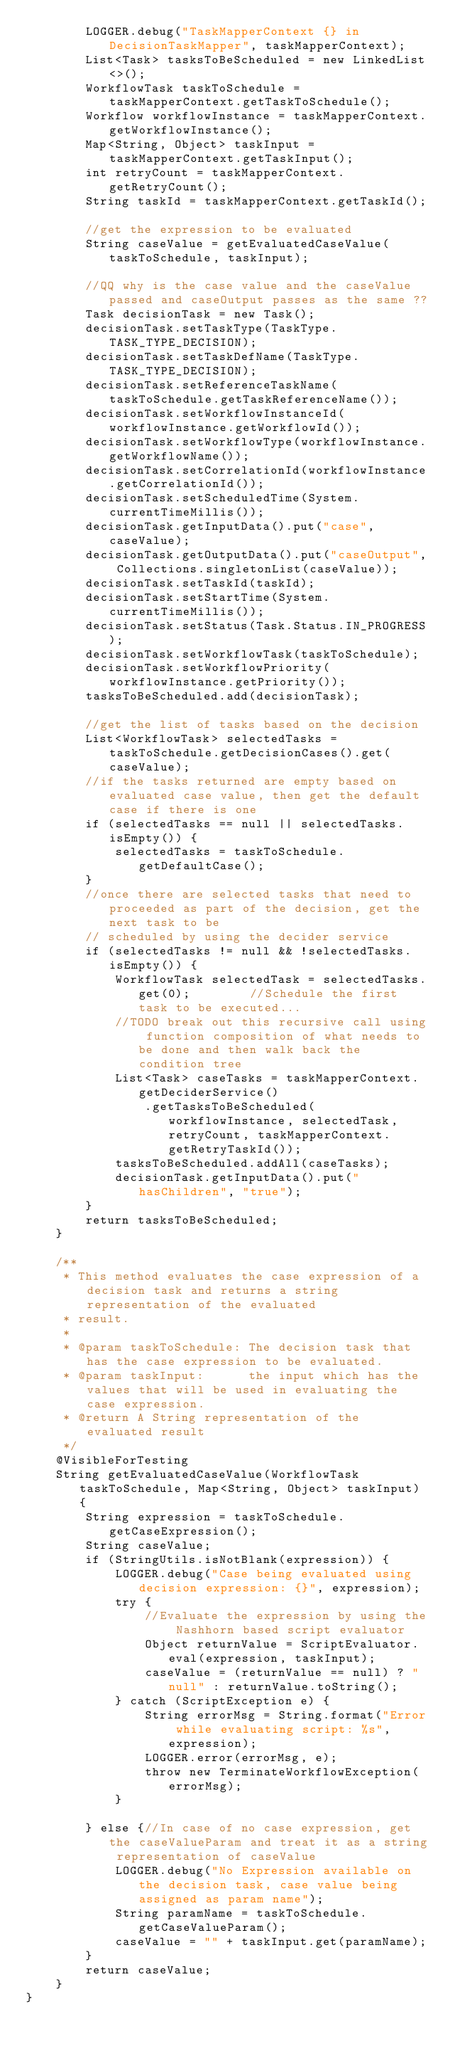<code> <loc_0><loc_0><loc_500><loc_500><_Java_>        LOGGER.debug("TaskMapperContext {} in DecisionTaskMapper", taskMapperContext);
        List<Task> tasksToBeScheduled = new LinkedList<>();
        WorkflowTask taskToSchedule = taskMapperContext.getTaskToSchedule();
        Workflow workflowInstance = taskMapperContext.getWorkflowInstance();
        Map<String, Object> taskInput = taskMapperContext.getTaskInput();
        int retryCount = taskMapperContext.getRetryCount();
        String taskId = taskMapperContext.getTaskId();

        //get the expression to be evaluated
        String caseValue = getEvaluatedCaseValue(taskToSchedule, taskInput);

        //QQ why is the case value and the caseValue passed and caseOutput passes as the same ??
        Task decisionTask = new Task();
        decisionTask.setTaskType(TaskType.TASK_TYPE_DECISION);
        decisionTask.setTaskDefName(TaskType.TASK_TYPE_DECISION);
        decisionTask.setReferenceTaskName(taskToSchedule.getTaskReferenceName());
        decisionTask.setWorkflowInstanceId(workflowInstance.getWorkflowId());
        decisionTask.setWorkflowType(workflowInstance.getWorkflowName());
        decisionTask.setCorrelationId(workflowInstance.getCorrelationId());
        decisionTask.setScheduledTime(System.currentTimeMillis());
        decisionTask.getInputData().put("case", caseValue);
        decisionTask.getOutputData().put("caseOutput", Collections.singletonList(caseValue));
        decisionTask.setTaskId(taskId);
        decisionTask.setStartTime(System.currentTimeMillis());
        decisionTask.setStatus(Task.Status.IN_PROGRESS);
        decisionTask.setWorkflowTask(taskToSchedule);
        decisionTask.setWorkflowPriority(workflowInstance.getPriority());
        tasksToBeScheduled.add(decisionTask);

        //get the list of tasks based on the decision
        List<WorkflowTask> selectedTasks = taskToSchedule.getDecisionCases().get(caseValue);
        //if the tasks returned are empty based on evaluated case value, then get the default case if there is one
        if (selectedTasks == null || selectedTasks.isEmpty()) {
            selectedTasks = taskToSchedule.getDefaultCase();
        }
        //once there are selected tasks that need to proceeded as part of the decision, get the next task to be
        // scheduled by using the decider service
        if (selectedTasks != null && !selectedTasks.isEmpty()) {
            WorkflowTask selectedTask = selectedTasks.get(0);        //Schedule the first task to be executed...
            //TODO break out this recursive call using function composition of what needs to be done and then walk back the condition tree
            List<Task> caseTasks = taskMapperContext.getDeciderService()
                .getTasksToBeScheduled(workflowInstance, selectedTask, retryCount, taskMapperContext.getRetryTaskId());
            tasksToBeScheduled.addAll(caseTasks);
            decisionTask.getInputData().put("hasChildren", "true");
        }
        return tasksToBeScheduled;
    }

    /**
     * This method evaluates the case expression of a decision task and returns a string representation of the evaluated
     * result.
     *
     * @param taskToSchedule: The decision task that has the case expression to be evaluated.
     * @param taskInput:      the input which has the values that will be used in evaluating the case expression.
     * @return A String representation of the evaluated result
     */
    @VisibleForTesting
    String getEvaluatedCaseValue(WorkflowTask taskToSchedule, Map<String, Object> taskInput) {
        String expression = taskToSchedule.getCaseExpression();
        String caseValue;
        if (StringUtils.isNotBlank(expression)) {
            LOGGER.debug("Case being evaluated using decision expression: {}", expression);
            try {
                //Evaluate the expression by using the Nashhorn based script evaluator
                Object returnValue = ScriptEvaluator.eval(expression, taskInput);
                caseValue = (returnValue == null) ? "null" : returnValue.toString();
            } catch (ScriptException e) {
                String errorMsg = String.format("Error while evaluating script: %s", expression);
                LOGGER.error(errorMsg, e);
                throw new TerminateWorkflowException(errorMsg);
            }

        } else {//In case of no case expression, get the caseValueParam and treat it as a string representation of caseValue
            LOGGER.debug("No Expression available on the decision task, case value being assigned as param name");
            String paramName = taskToSchedule.getCaseValueParam();
            caseValue = "" + taskInput.get(paramName);
        }
        return caseValue;
    }
}
</code> 